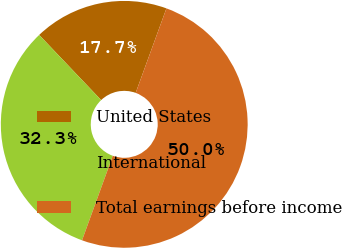<chart> <loc_0><loc_0><loc_500><loc_500><pie_chart><fcel>United States<fcel>International<fcel>Total earnings before income<nl><fcel>17.66%<fcel>32.34%<fcel>50.0%<nl></chart> 